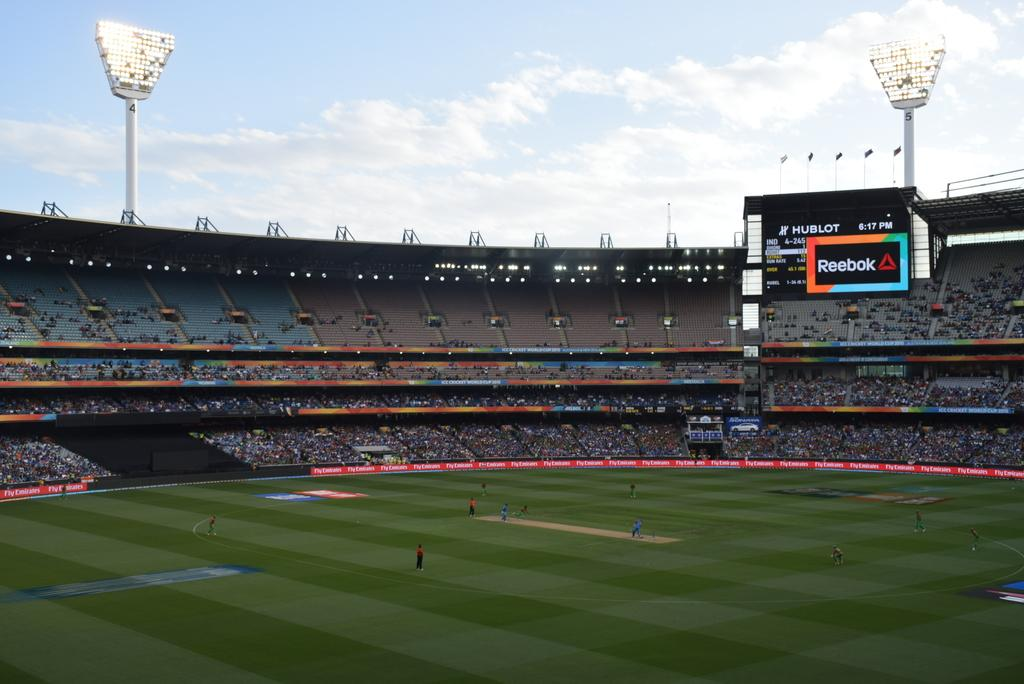<image>
Provide a brief description of the given image. A baseball game is underway in the Reebok stadium. 